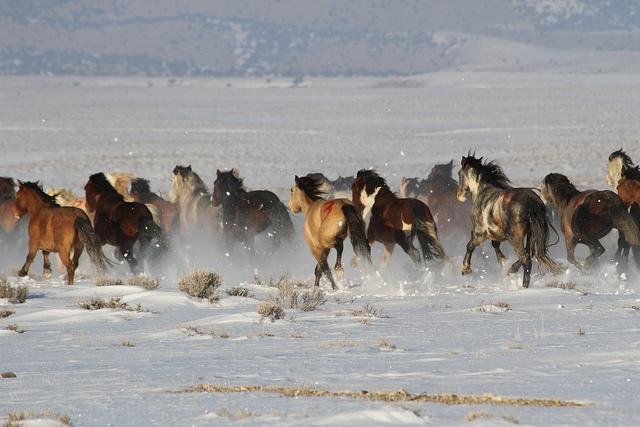How many horses can be seen?
Give a very brief answer. 9. 